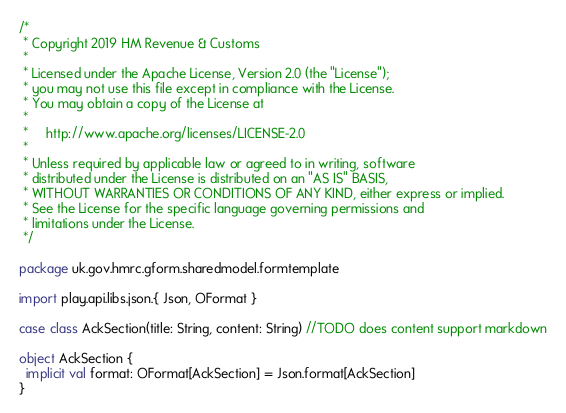<code> <loc_0><loc_0><loc_500><loc_500><_Scala_>/*
 * Copyright 2019 HM Revenue & Customs
 *
 * Licensed under the Apache License, Version 2.0 (the "License");
 * you may not use this file except in compliance with the License.
 * You may obtain a copy of the License at
 *
 *     http://www.apache.org/licenses/LICENSE-2.0
 *
 * Unless required by applicable law or agreed to in writing, software
 * distributed under the License is distributed on an "AS IS" BASIS,
 * WITHOUT WARRANTIES OR CONDITIONS OF ANY KIND, either express or implied.
 * See the License for the specific language governing permissions and
 * limitations under the License.
 */

package uk.gov.hmrc.gform.sharedmodel.formtemplate

import play.api.libs.json.{ Json, OFormat }

case class AckSection(title: String, content: String) //TODO does content support markdown

object AckSection {
  implicit val format: OFormat[AckSection] = Json.format[AckSection]
}
</code> 